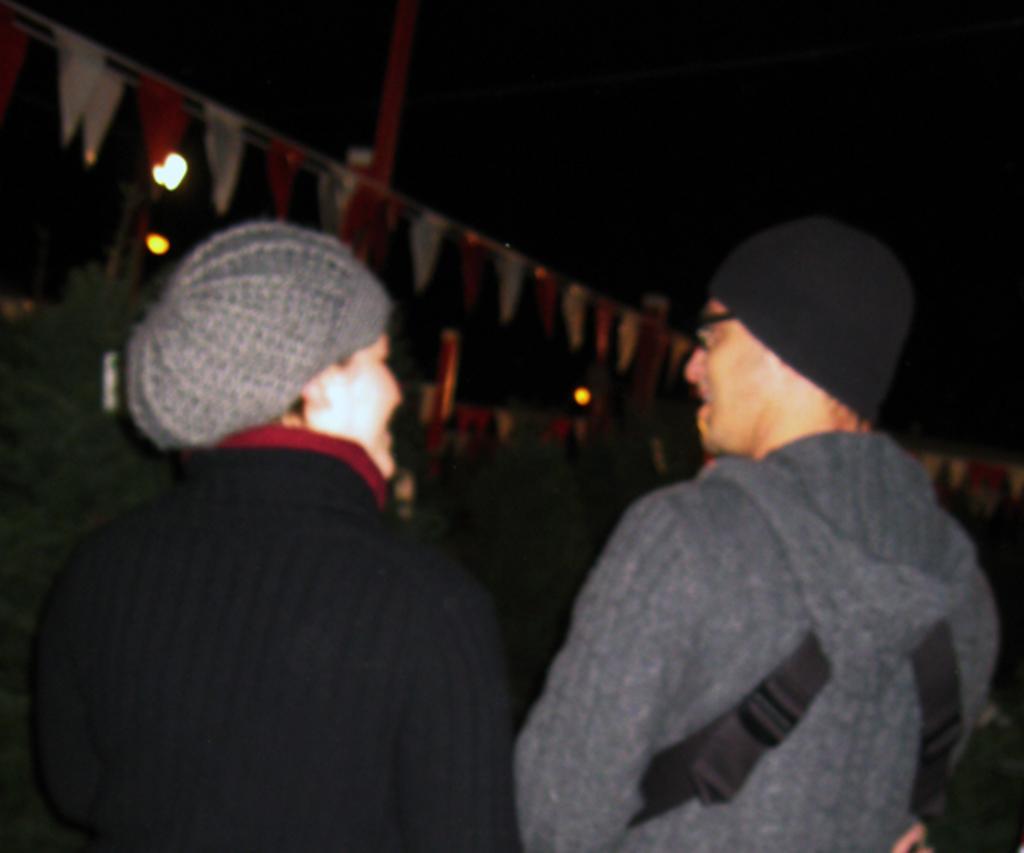Describe this image in one or two sentences. In this image we can see two persons, there are some decorative papers attached to the ropes, there is a pole, there are lights, also the background is dark. 